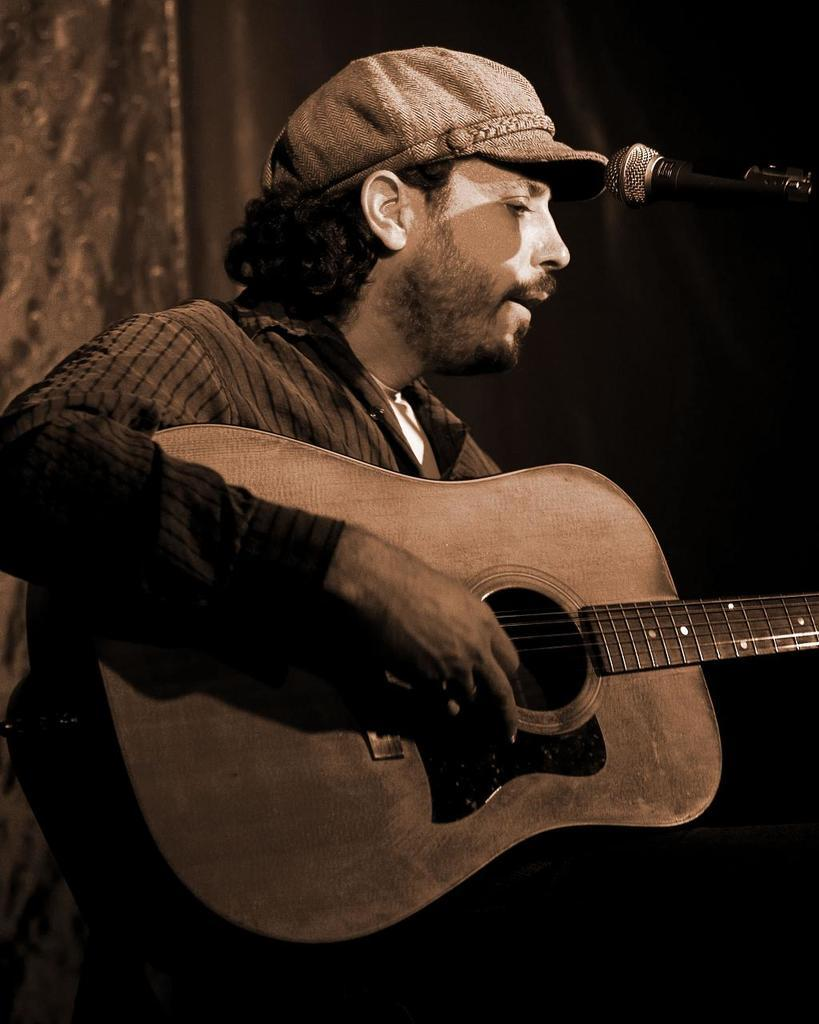Who is the main subject in the image? There is a man in the image. What is the man holding in the image? The man is holding a guitar. What object is near the man in the image? The man is near a microphone. What type of headwear is the man wearing in the image? The man is wearing a cap. What notes can be seen in the notebook that the man is using in the image? There is no notebook present in the image; the man is holding a guitar and standing near a microphone. 